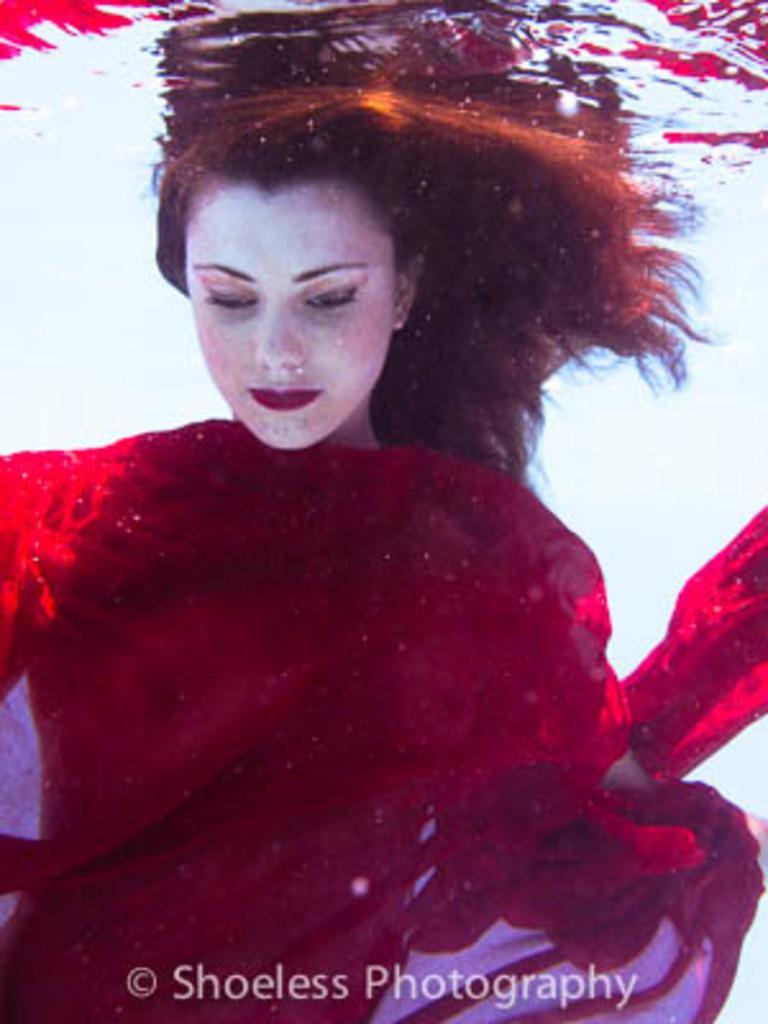Please provide a concise description of this image. In this image we can see a person in the water. There is a watermark at the bottom of the image. 